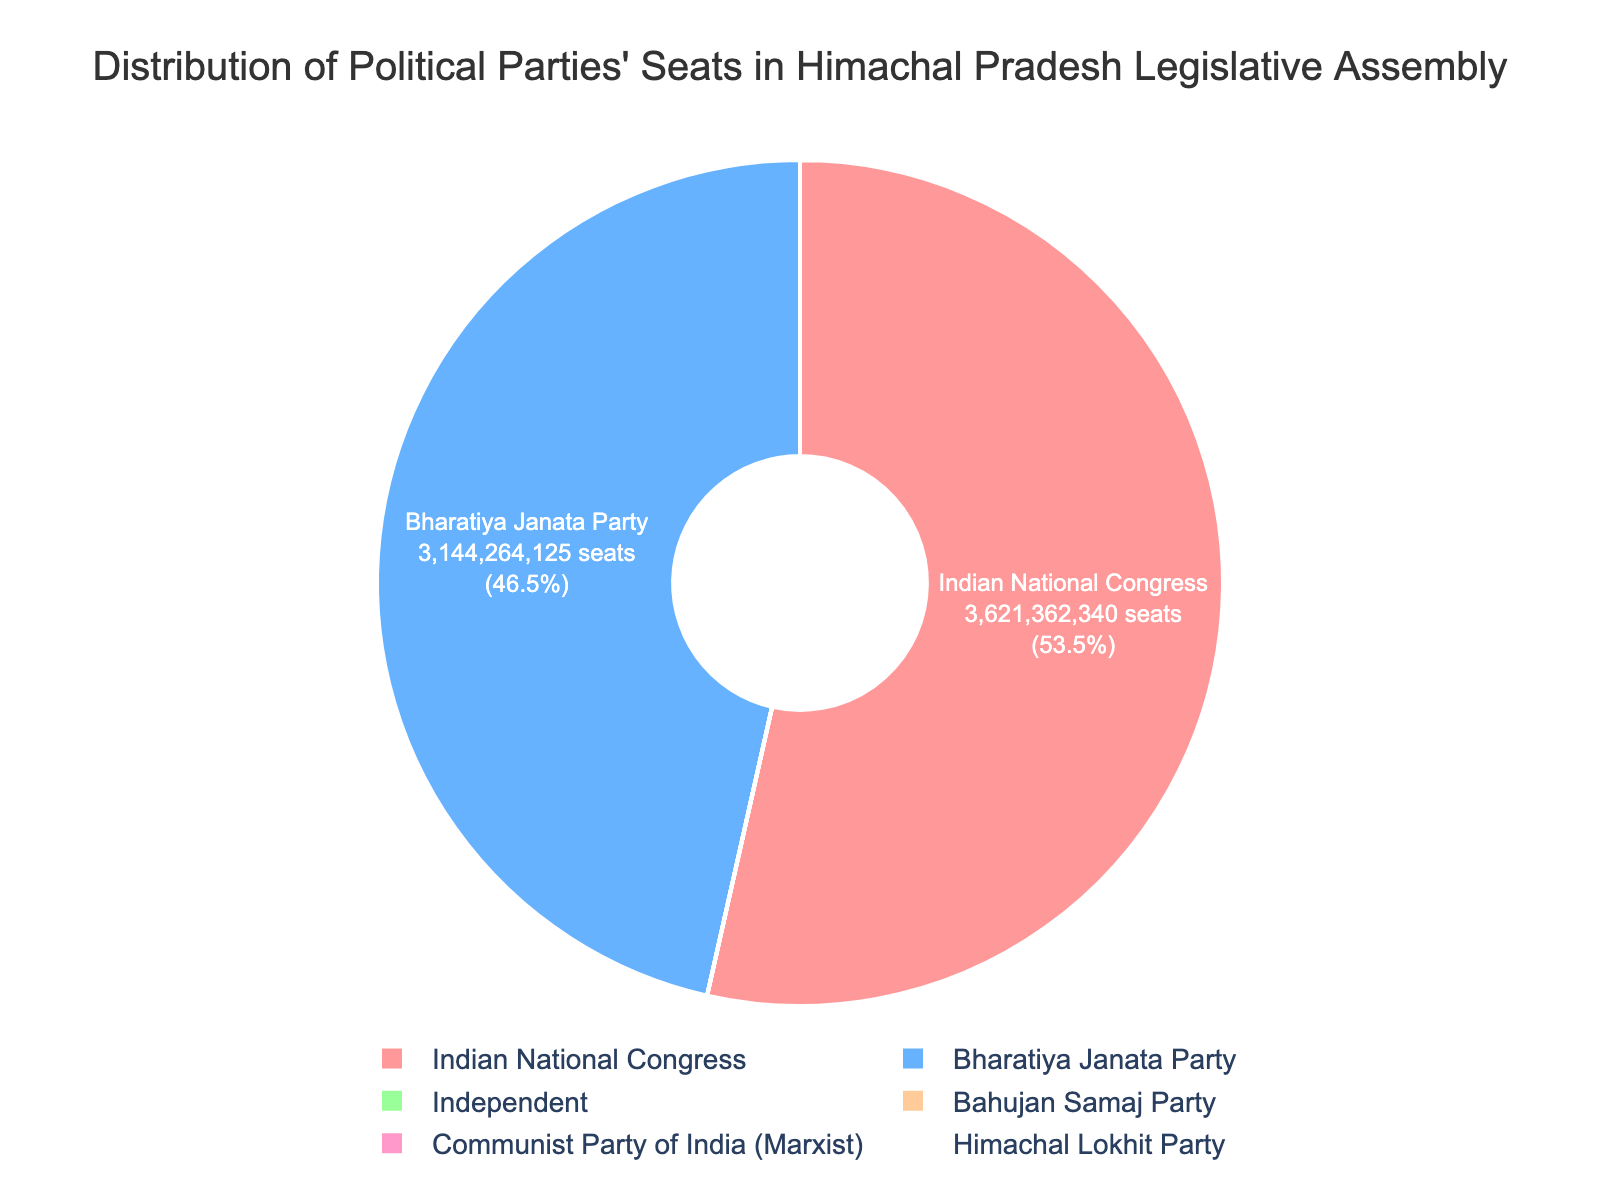Which party has secured the highest total number of seats over the last five elections? Sum up the seats for each party and compare: Indian National Congress (36+21+36+23+40 = 156), Bharatiya Janata Party (31+44+26+41+25 = 167). BJP has the highest total seats.
Answer: Bharatiya Janata Party What's the difference in total number of seats between the Indian National Congress and Bharatiya Janata Party over the last five elections? Calculate the total seats for each party: Indian National Congress (36+21+36+23+40 = 156), Bharatiya Janata Party (31+44+26+41+25 = 167). The difference is 167 - 156 = 11.
Answer: 11 How many seats did parties other than the Indian National Congress and Bharatiya Janata Party secure in total over the last five elections? Sum the seats for non-major parties: CPI(M) (1), Himachal Lokhit Party (1), Bahujan Samaj Party (1), Independent (1+2+5+3+3 = 14). Total = 1 + 1 + 1 + 14 = 17.
Answer: 17 Which election had the highest number of seats won by Independent candidates? Compare the number of seats won by Independents in each election: (1, 2, 5, 3, 3). The highest is 5 seats.
Answer: The election with 5 Independent seats What percentage of seats were won by the Indian National Congress overall? Calculate the total seats won by all parties: (36+31+1 + 44+21+1+2 + 36+26+5+1 + 41+23+3+1 + 40+25+3 = 340). Indian National Congress won 156 seats. The percentage is (156 / 340) * 100 ≈ 45.88%.
Answer: 45.88% What party has the lowest total number of seats, and how many seats did it win? Calculate total seats for all parties and find the minimum: CPI(M) (1), Himachal Lokhit Party (1), Bahujan Samaj Party (1), Independents (14). The CPI(M), Himachal Lokhit Party, and Bahujan Samaj Party each have 1 seat, the lowest.
Answer: CPI(M), Himachal Lokhit Party, Bahujan Samaj Party; 1 seat each Compare the total number of seats won by Independent candidates to those won by the Himachal Lokhit Party. Independent candidates won 1+2+5+3+3=14 seats. Himachal Lokhit Party won 1 seat. Independents have more seats.
Answer: Independents have more seats Did the Bharatiya Janata Party or Indian National Congress win more seats in the second election? Compare seats in the second election: BJP (44), Congress (21). BJP won more seats.
Answer: Bharatiya Janata Party In which election did the Indian National Congress win the most seats? Compare the seats across all elections: 36, 21, 36, 23, 40. The highest is 40 seats.
Answer: The election with 40 seats What is the combined total of all seats won by Independent candidates and the Bahujan Samaj Party? Sum the seats for Independent (1+2+5+3+3 = 14) and Bahujan Samaj Party (1). Combined total = 14 + 1 = 15.
Answer: 15 